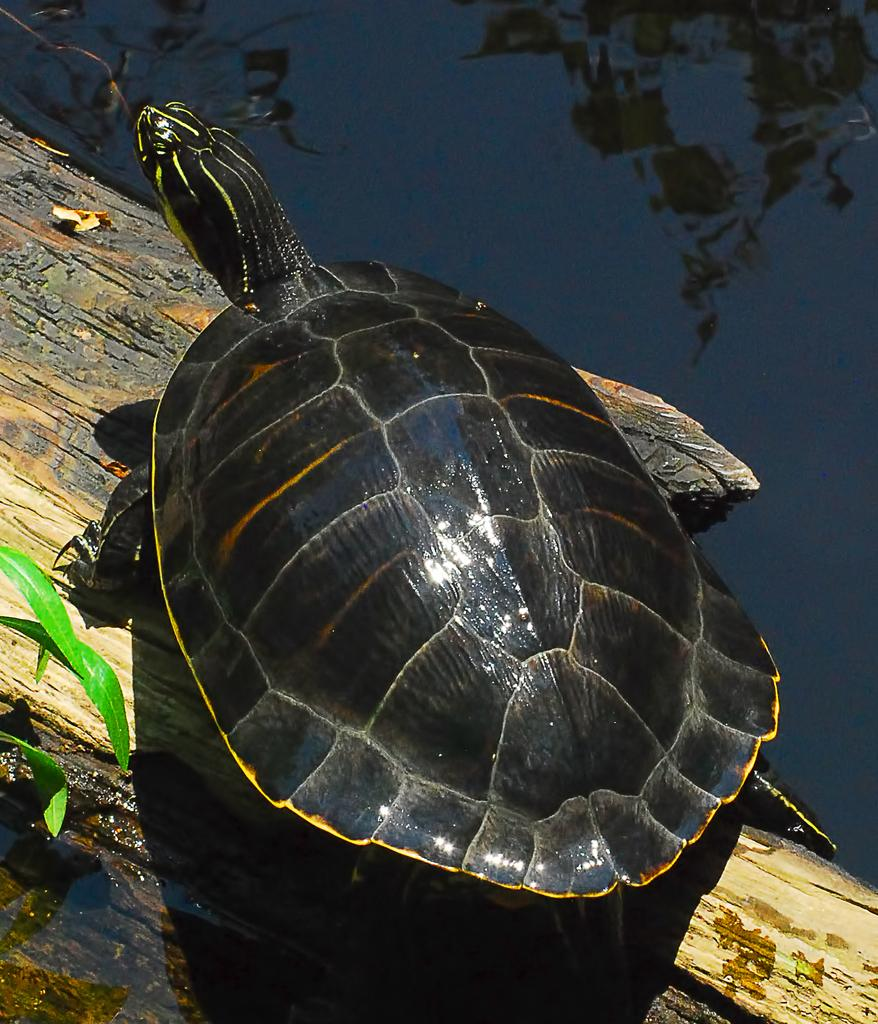What animal is present in the image? There is a turtle in the image. What type of surface is the turtle on? The turtle is on a wooden surface. What type of natural elements can be seen in the image? Leaves and water are visible in the image. What shape is the lamp in the image? There is no lamp present in the image. 